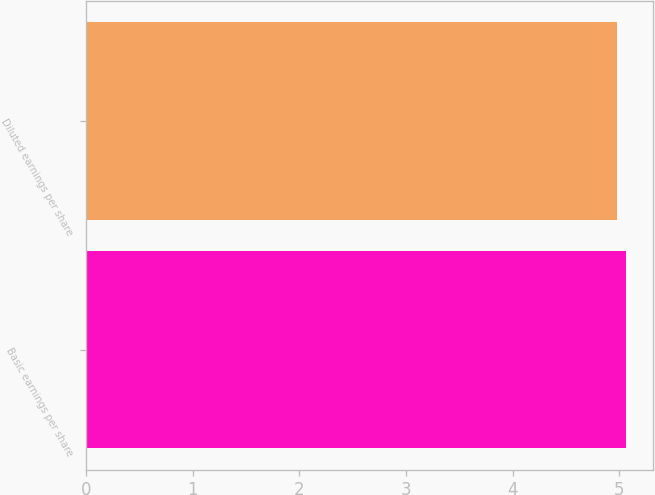<chart> <loc_0><loc_0><loc_500><loc_500><bar_chart><fcel>Basic earnings per share<fcel>Diluted earnings per share<nl><fcel>5.06<fcel>4.98<nl></chart> 